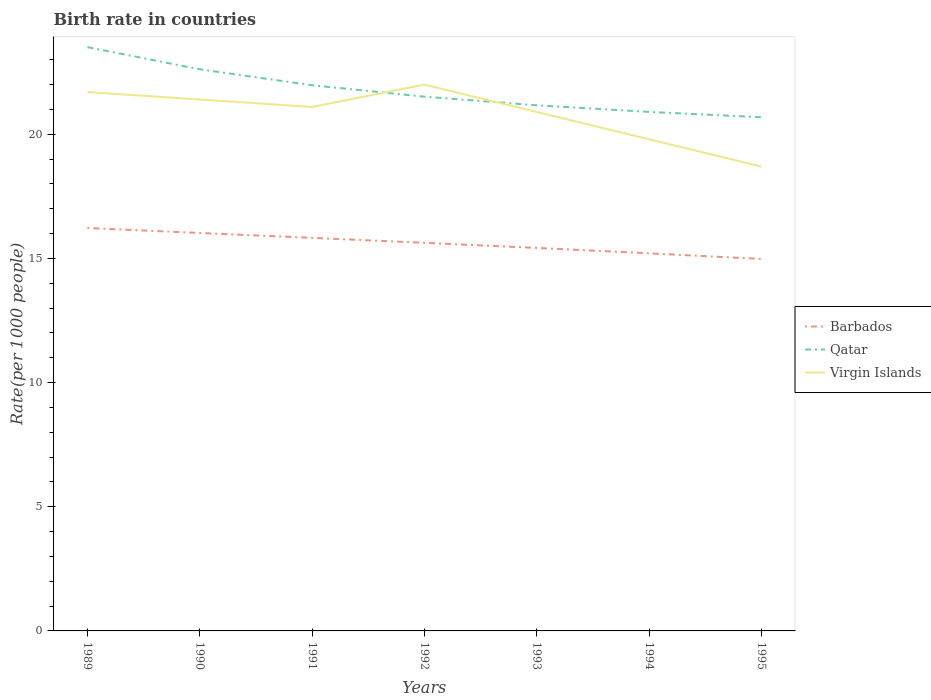Does the line corresponding to Virgin Islands intersect with the line corresponding to Barbados?
Your answer should be compact. No. Is the number of lines equal to the number of legend labels?
Your response must be concise. Yes. Across all years, what is the maximum birth rate in Barbados?
Make the answer very short. 14.98. What is the total birth rate in Qatar in the graph?
Keep it short and to the point. 2.61. What is the difference between the highest and the second highest birth rate in Virgin Islands?
Provide a succinct answer. 3.3. How many years are there in the graph?
Make the answer very short. 7. What is the difference between two consecutive major ticks on the Y-axis?
Give a very brief answer. 5. Are the values on the major ticks of Y-axis written in scientific E-notation?
Your answer should be very brief. No. Where does the legend appear in the graph?
Offer a terse response. Center right. How are the legend labels stacked?
Make the answer very short. Vertical. What is the title of the graph?
Your answer should be very brief. Birth rate in countries. Does "Middle East & North Africa (all income levels)" appear as one of the legend labels in the graph?
Offer a terse response. No. What is the label or title of the X-axis?
Your answer should be compact. Years. What is the label or title of the Y-axis?
Your response must be concise. Rate(per 1000 people). What is the Rate(per 1000 people) in Barbados in 1989?
Your answer should be very brief. 16.23. What is the Rate(per 1000 people) of Qatar in 1989?
Offer a terse response. 23.51. What is the Rate(per 1000 people) in Virgin Islands in 1989?
Make the answer very short. 21.7. What is the Rate(per 1000 people) in Barbados in 1990?
Give a very brief answer. 16.02. What is the Rate(per 1000 people) in Qatar in 1990?
Make the answer very short. 22.62. What is the Rate(per 1000 people) of Virgin Islands in 1990?
Provide a succinct answer. 21.4. What is the Rate(per 1000 people) in Barbados in 1991?
Your answer should be very brief. 15.83. What is the Rate(per 1000 people) in Qatar in 1991?
Your answer should be very brief. 21.98. What is the Rate(per 1000 people) in Virgin Islands in 1991?
Your response must be concise. 21.1. What is the Rate(per 1000 people) in Barbados in 1992?
Your answer should be very brief. 15.63. What is the Rate(per 1000 people) of Qatar in 1992?
Offer a terse response. 21.51. What is the Rate(per 1000 people) of Virgin Islands in 1992?
Your response must be concise. 22. What is the Rate(per 1000 people) in Barbados in 1993?
Keep it short and to the point. 15.42. What is the Rate(per 1000 people) in Qatar in 1993?
Ensure brevity in your answer.  21.17. What is the Rate(per 1000 people) of Virgin Islands in 1993?
Provide a succinct answer. 20.9. What is the Rate(per 1000 people) of Barbados in 1994?
Offer a very short reply. 15.21. What is the Rate(per 1000 people) in Qatar in 1994?
Keep it short and to the point. 20.9. What is the Rate(per 1000 people) of Virgin Islands in 1994?
Offer a very short reply. 19.8. What is the Rate(per 1000 people) in Barbados in 1995?
Keep it short and to the point. 14.98. What is the Rate(per 1000 people) of Qatar in 1995?
Offer a terse response. 20.69. Across all years, what is the maximum Rate(per 1000 people) in Barbados?
Provide a succinct answer. 16.23. Across all years, what is the maximum Rate(per 1000 people) in Qatar?
Make the answer very short. 23.51. Across all years, what is the maximum Rate(per 1000 people) in Virgin Islands?
Your answer should be compact. 22. Across all years, what is the minimum Rate(per 1000 people) in Barbados?
Your response must be concise. 14.98. Across all years, what is the minimum Rate(per 1000 people) of Qatar?
Ensure brevity in your answer.  20.69. What is the total Rate(per 1000 people) of Barbados in the graph?
Keep it short and to the point. 109.32. What is the total Rate(per 1000 people) of Qatar in the graph?
Your answer should be compact. 152.37. What is the total Rate(per 1000 people) of Virgin Islands in the graph?
Your answer should be compact. 145.6. What is the difference between the Rate(per 1000 people) of Barbados in 1989 and that in 1990?
Provide a short and direct response. 0.2. What is the difference between the Rate(per 1000 people) in Qatar in 1989 and that in 1990?
Provide a short and direct response. 0.89. What is the difference between the Rate(per 1000 people) of Barbados in 1989 and that in 1991?
Your response must be concise. 0.4. What is the difference between the Rate(per 1000 people) in Qatar in 1989 and that in 1991?
Give a very brief answer. 1.53. What is the difference between the Rate(per 1000 people) in Barbados in 1989 and that in 1992?
Your answer should be very brief. 0.6. What is the difference between the Rate(per 1000 people) of Qatar in 1989 and that in 1992?
Your response must be concise. 1.99. What is the difference between the Rate(per 1000 people) of Barbados in 1989 and that in 1993?
Make the answer very short. 0.8. What is the difference between the Rate(per 1000 people) of Qatar in 1989 and that in 1993?
Keep it short and to the point. 2.34. What is the difference between the Rate(per 1000 people) in Barbados in 1989 and that in 1994?
Ensure brevity in your answer.  1.02. What is the difference between the Rate(per 1000 people) of Qatar in 1989 and that in 1994?
Give a very brief answer. 2.61. What is the difference between the Rate(per 1000 people) of Barbados in 1989 and that in 1995?
Your response must be concise. 1.25. What is the difference between the Rate(per 1000 people) in Qatar in 1989 and that in 1995?
Give a very brief answer. 2.82. What is the difference between the Rate(per 1000 people) of Virgin Islands in 1989 and that in 1995?
Your answer should be very brief. 3. What is the difference between the Rate(per 1000 people) in Barbados in 1990 and that in 1991?
Provide a short and direct response. 0.2. What is the difference between the Rate(per 1000 people) in Qatar in 1990 and that in 1991?
Your response must be concise. 0.64. What is the difference between the Rate(per 1000 people) in Virgin Islands in 1990 and that in 1991?
Make the answer very short. 0.3. What is the difference between the Rate(per 1000 people) of Barbados in 1990 and that in 1992?
Your answer should be very brief. 0.4. What is the difference between the Rate(per 1000 people) of Qatar in 1990 and that in 1992?
Offer a terse response. 1.1. What is the difference between the Rate(per 1000 people) of Virgin Islands in 1990 and that in 1992?
Offer a terse response. -0.6. What is the difference between the Rate(per 1000 people) in Barbados in 1990 and that in 1993?
Offer a very short reply. 0.6. What is the difference between the Rate(per 1000 people) of Qatar in 1990 and that in 1993?
Make the answer very short. 1.45. What is the difference between the Rate(per 1000 people) in Virgin Islands in 1990 and that in 1993?
Give a very brief answer. 0.5. What is the difference between the Rate(per 1000 people) in Barbados in 1990 and that in 1994?
Offer a terse response. 0.82. What is the difference between the Rate(per 1000 people) of Qatar in 1990 and that in 1994?
Make the answer very short. 1.72. What is the difference between the Rate(per 1000 people) in Barbados in 1990 and that in 1995?
Ensure brevity in your answer.  1.05. What is the difference between the Rate(per 1000 people) in Qatar in 1990 and that in 1995?
Your answer should be very brief. 1.93. What is the difference between the Rate(per 1000 people) of Barbados in 1991 and that in 1992?
Make the answer very short. 0.2. What is the difference between the Rate(per 1000 people) in Qatar in 1991 and that in 1992?
Give a very brief answer. 0.46. What is the difference between the Rate(per 1000 people) in Barbados in 1991 and that in 1993?
Offer a terse response. 0.41. What is the difference between the Rate(per 1000 people) in Qatar in 1991 and that in 1993?
Offer a very short reply. 0.81. What is the difference between the Rate(per 1000 people) in Virgin Islands in 1991 and that in 1993?
Provide a short and direct response. 0.2. What is the difference between the Rate(per 1000 people) of Barbados in 1991 and that in 1994?
Keep it short and to the point. 0.62. What is the difference between the Rate(per 1000 people) in Qatar in 1991 and that in 1994?
Make the answer very short. 1.07. What is the difference between the Rate(per 1000 people) in Virgin Islands in 1991 and that in 1994?
Offer a terse response. 1.3. What is the difference between the Rate(per 1000 people) of Barbados in 1991 and that in 1995?
Make the answer very short. 0.85. What is the difference between the Rate(per 1000 people) of Qatar in 1991 and that in 1995?
Your answer should be compact. 1.29. What is the difference between the Rate(per 1000 people) in Virgin Islands in 1991 and that in 1995?
Provide a succinct answer. 2.4. What is the difference between the Rate(per 1000 people) in Barbados in 1992 and that in 1993?
Your answer should be compact. 0.21. What is the difference between the Rate(per 1000 people) of Qatar in 1992 and that in 1993?
Provide a succinct answer. 0.35. What is the difference between the Rate(per 1000 people) of Virgin Islands in 1992 and that in 1993?
Provide a succinct answer. 1.1. What is the difference between the Rate(per 1000 people) of Barbados in 1992 and that in 1994?
Keep it short and to the point. 0.42. What is the difference between the Rate(per 1000 people) of Qatar in 1992 and that in 1994?
Keep it short and to the point. 0.61. What is the difference between the Rate(per 1000 people) of Virgin Islands in 1992 and that in 1994?
Your answer should be compact. 2.2. What is the difference between the Rate(per 1000 people) of Barbados in 1992 and that in 1995?
Offer a very short reply. 0.65. What is the difference between the Rate(per 1000 people) of Qatar in 1992 and that in 1995?
Your answer should be compact. 0.83. What is the difference between the Rate(per 1000 people) of Barbados in 1993 and that in 1994?
Give a very brief answer. 0.22. What is the difference between the Rate(per 1000 people) in Qatar in 1993 and that in 1994?
Make the answer very short. 0.27. What is the difference between the Rate(per 1000 people) in Barbados in 1993 and that in 1995?
Provide a short and direct response. 0.44. What is the difference between the Rate(per 1000 people) of Qatar in 1993 and that in 1995?
Provide a short and direct response. 0.48. What is the difference between the Rate(per 1000 people) in Barbados in 1994 and that in 1995?
Ensure brevity in your answer.  0.23. What is the difference between the Rate(per 1000 people) of Qatar in 1994 and that in 1995?
Make the answer very short. 0.21. What is the difference between the Rate(per 1000 people) in Virgin Islands in 1994 and that in 1995?
Offer a terse response. 1.1. What is the difference between the Rate(per 1000 people) of Barbados in 1989 and the Rate(per 1000 people) of Qatar in 1990?
Keep it short and to the point. -6.39. What is the difference between the Rate(per 1000 people) of Barbados in 1989 and the Rate(per 1000 people) of Virgin Islands in 1990?
Make the answer very short. -5.17. What is the difference between the Rate(per 1000 people) of Qatar in 1989 and the Rate(per 1000 people) of Virgin Islands in 1990?
Provide a succinct answer. 2.11. What is the difference between the Rate(per 1000 people) in Barbados in 1989 and the Rate(per 1000 people) in Qatar in 1991?
Your answer should be very brief. -5.75. What is the difference between the Rate(per 1000 people) in Barbados in 1989 and the Rate(per 1000 people) in Virgin Islands in 1991?
Your answer should be compact. -4.87. What is the difference between the Rate(per 1000 people) in Qatar in 1989 and the Rate(per 1000 people) in Virgin Islands in 1991?
Offer a terse response. 2.41. What is the difference between the Rate(per 1000 people) in Barbados in 1989 and the Rate(per 1000 people) in Qatar in 1992?
Ensure brevity in your answer.  -5.29. What is the difference between the Rate(per 1000 people) of Barbados in 1989 and the Rate(per 1000 people) of Virgin Islands in 1992?
Offer a very short reply. -5.77. What is the difference between the Rate(per 1000 people) of Qatar in 1989 and the Rate(per 1000 people) of Virgin Islands in 1992?
Provide a short and direct response. 1.51. What is the difference between the Rate(per 1000 people) in Barbados in 1989 and the Rate(per 1000 people) in Qatar in 1993?
Provide a succinct answer. -4.94. What is the difference between the Rate(per 1000 people) in Barbados in 1989 and the Rate(per 1000 people) in Virgin Islands in 1993?
Ensure brevity in your answer.  -4.67. What is the difference between the Rate(per 1000 people) in Qatar in 1989 and the Rate(per 1000 people) in Virgin Islands in 1993?
Give a very brief answer. 2.61. What is the difference between the Rate(per 1000 people) in Barbados in 1989 and the Rate(per 1000 people) in Qatar in 1994?
Your answer should be very brief. -4.67. What is the difference between the Rate(per 1000 people) in Barbados in 1989 and the Rate(per 1000 people) in Virgin Islands in 1994?
Make the answer very short. -3.57. What is the difference between the Rate(per 1000 people) of Qatar in 1989 and the Rate(per 1000 people) of Virgin Islands in 1994?
Your answer should be compact. 3.71. What is the difference between the Rate(per 1000 people) in Barbados in 1989 and the Rate(per 1000 people) in Qatar in 1995?
Make the answer very short. -4.46. What is the difference between the Rate(per 1000 people) in Barbados in 1989 and the Rate(per 1000 people) in Virgin Islands in 1995?
Make the answer very short. -2.47. What is the difference between the Rate(per 1000 people) of Qatar in 1989 and the Rate(per 1000 people) of Virgin Islands in 1995?
Provide a succinct answer. 4.81. What is the difference between the Rate(per 1000 people) in Barbados in 1990 and the Rate(per 1000 people) in Qatar in 1991?
Your answer should be very brief. -5.95. What is the difference between the Rate(per 1000 people) of Barbados in 1990 and the Rate(per 1000 people) of Virgin Islands in 1991?
Your answer should be compact. -5.08. What is the difference between the Rate(per 1000 people) in Qatar in 1990 and the Rate(per 1000 people) in Virgin Islands in 1991?
Give a very brief answer. 1.52. What is the difference between the Rate(per 1000 people) of Barbados in 1990 and the Rate(per 1000 people) of Qatar in 1992?
Provide a succinct answer. -5.49. What is the difference between the Rate(per 1000 people) in Barbados in 1990 and the Rate(per 1000 people) in Virgin Islands in 1992?
Offer a very short reply. -5.97. What is the difference between the Rate(per 1000 people) in Qatar in 1990 and the Rate(per 1000 people) in Virgin Islands in 1992?
Make the answer very short. 0.62. What is the difference between the Rate(per 1000 people) in Barbados in 1990 and the Rate(per 1000 people) in Qatar in 1993?
Ensure brevity in your answer.  -5.14. What is the difference between the Rate(per 1000 people) in Barbados in 1990 and the Rate(per 1000 people) in Virgin Islands in 1993?
Your answer should be compact. -4.88. What is the difference between the Rate(per 1000 people) of Qatar in 1990 and the Rate(per 1000 people) of Virgin Islands in 1993?
Keep it short and to the point. 1.72. What is the difference between the Rate(per 1000 people) in Barbados in 1990 and the Rate(per 1000 people) in Qatar in 1994?
Make the answer very short. -4.88. What is the difference between the Rate(per 1000 people) in Barbados in 1990 and the Rate(per 1000 people) in Virgin Islands in 1994?
Your answer should be very brief. -3.77. What is the difference between the Rate(per 1000 people) of Qatar in 1990 and the Rate(per 1000 people) of Virgin Islands in 1994?
Ensure brevity in your answer.  2.82. What is the difference between the Rate(per 1000 people) of Barbados in 1990 and the Rate(per 1000 people) of Qatar in 1995?
Make the answer very short. -4.66. What is the difference between the Rate(per 1000 people) in Barbados in 1990 and the Rate(per 1000 people) in Virgin Islands in 1995?
Keep it short and to the point. -2.67. What is the difference between the Rate(per 1000 people) of Qatar in 1990 and the Rate(per 1000 people) of Virgin Islands in 1995?
Keep it short and to the point. 3.92. What is the difference between the Rate(per 1000 people) in Barbados in 1991 and the Rate(per 1000 people) in Qatar in 1992?
Make the answer very short. -5.68. What is the difference between the Rate(per 1000 people) in Barbados in 1991 and the Rate(per 1000 people) in Virgin Islands in 1992?
Your answer should be compact. -6.17. What is the difference between the Rate(per 1000 people) in Qatar in 1991 and the Rate(per 1000 people) in Virgin Islands in 1992?
Offer a terse response. -0.03. What is the difference between the Rate(per 1000 people) in Barbados in 1991 and the Rate(per 1000 people) in Qatar in 1993?
Your answer should be very brief. -5.34. What is the difference between the Rate(per 1000 people) of Barbados in 1991 and the Rate(per 1000 people) of Virgin Islands in 1993?
Offer a very short reply. -5.07. What is the difference between the Rate(per 1000 people) in Qatar in 1991 and the Rate(per 1000 people) in Virgin Islands in 1993?
Make the answer very short. 1.07. What is the difference between the Rate(per 1000 people) of Barbados in 1991 and the Rate(per 1000 people) of Qatar in 1994?
Give a very brief answer. -5.07. What is the difference between the Rate(per 1000 people) in Barbados in 1991 and the Rate(per 1000 people) in Virgin Islands in 1994?
Keep it short and to the point. -3.97. What is the difference between the Rate(per 1000 people) of Qatar in 1991 and the Rate(per 1000 people) of Virgin Islands in 1994?
Your response must be concise. 2.17. What is the difference between the Rate(per 1000 people) in Barbados in 1991 and the Rate(per 1000 people) in Qatar in 1995?
Offer a terse response. -4.86. What is the difference between the Rate(per 1000 people) of Barbados in 1991 and the Rate(per 1000 people) of Virgin Islands in 1995?
Offer a terse response. -2.87. What is the difference between the Rate(per 1000 people) in Qatar in 1991 and the Rate(per 1000 people) in Virgin Islands in 1995?
Your answer should be very brief. 3.27. What is the difference between the Rate(per 1000 people) in Barbados in 1992 and the Rate(per 1000 people) in Qatar in 1993?
Make the answer very short. -5.54. What is the difference between the Rate(per 1000 people) of Barbados in 1992 and the Rate(per 1000 people) of Virgin Islands in 1993?
Your answer should be compact. -5.27. What is the difference between the Rate(per 1000 people) of Qatar in 1992 and the Rate(per 1000 people) of Virgin Islands in 1993?
Provide a succinct answer. 0.61. What is the difference between the Rate(per 1000 people) in Barbados in 1992 and the Rate(per 1000 people) in Qatar in 1994?
Your answer should be compact. -5.27. What is the difference between the Rate(per 1000 people) in Barbados in 1992 and the Rate(per 1000 people) in Virgin Islands in 1994?
Keep it short and to the point. -4.17. What is the difference between the Rate(per 1000 people) of Qatar in 1992 and the Rate(per 1000 people) of Virgin Islands in 1994?
Provide a short and direct response. 1.71. What is the difference between the Rate(per 1000 people) in Barbados in 1992 and the Rate(per 1000 people) in Qatar in 1995?
Offer a very short reply. -5.06. What is the difference between the Rate(per 1000 people) of Barbados in 1992 and the Rate(per 1000 people) of Virgin Islands in 1995?
Your answer should be very brief. -3.07. What is the difference between the Rate(per 1000 people) in Qatar in 1992 and the Rate(per 1000 people) in Virgin Islands in 1995?
Your answer should be very brief. 2.81. What is the difference between the Rate(per 1000 people) in Barbados in 1993 and the Rate(per 1000 people) in Qatar in 1994?
Offer a terse response. -5.48. What is the difference between the Rate(per 1000 people) of Barbados in 1993 and the Rate(per 1000 people) of Virgin Islands in 1994?
Offer a terse response. -4.38. What is the difference between the Rate(per 1000 people) in Qatar in 1993 and the Rate(per 1000 people) in Virgin Islands in 1994?
Offer a terse response. 1.37. What is the difference between the Rate(per 1000 people) in Barbados in 1993 and the Rate(per 1000 people) in Qatar in 1995?
Provide a short and direct response. -5.26. What is the difference between the Rate(per 1000 people) of Barbados in 1993 and the Rate(per 1000 people) of Virgin Islands in 1995?
Keep it short and to the point. -3.28. What is the difference between the Rate(per 1000 people) of Qatar in 1993 and the Rate(per 1000 people) of Virgin Islands in 1995?
Ensure brevity in your answer.  2.47. What is the difference between the Rate(per 1000 people) in Barbados in 1994 and the Rate(per 1000 people) in Qatar in 1995?
Ensure brevity in your answer.  -5.48. What is the difference between the Rate(per 1000 people) of Barbados in 1994 and the Rate(per 1000 people) of Virgin Islands in 1995?
Your answer should be very brief. -3.49. What is the difference between the Rate(per 1000 people) in Qatar in 1994 and the Rate(per 1000 people) in Virgin Islands in 1995?
Give a very brief answer. 2.2. What is the average Rate(per 1000 people) in Barbados per year?
Provide a short and direct response. 15.62. What is the average Rate(per 1000 people) of Qatar per year?
Give a very brief answer. 21.77. What is the average Rate(per 1000 people) in Virgin Islands per year?
Give a very brief answer. 20.8. In the year 1989, what is the difference between the Rate(per 1000 people) of Barbados and Rate(per 1000 people) of Qatar?
Keep it short and to the point. -7.28. In the year 1989, what is the difference between the Rate(per 1000 people) in Barbados and Rate(per 1000 people) in Virgin Islands?
Provide a short and direct response. -5.47. In the year 1989, what is the difference between the Rate(per 1000 people) of Qatar and Rate(per 1000 people) of Virgin Islands?
Your answer should be compact. 1.81. In the year 1990, what is the difference between the Rate(per 1000 people) of Barbados and Rate(per 1000 people) of Qatar?
Make the answer very short. -6.59. In the year 1990, what is the difference between the Rate(per 1000 people) of Barbados and Rate(per 1000 people) of Virgin Islands?
Offer a very short reply. -5.38. In the year 1990, what is the difference between the Rate(per 1000 people) in Qatar and Rate(per 1000 people) in Virgin Islands?
Your answer should be compact. 1.22. In the year 1991, what is the difference between the Rate(per 1000 people) in Barbados and Rate(per 1000 people) in Qatar?
Keep it short and to the point. -6.15. In the year 1991, what is the difference between the Rate(per 1000 people) of Barbados and Rate(per 1000 people) of Virgin Islands?
Keep it short and to the point. -5.27. In the year 1991, what is the difference between the Rate(per 1000 people) in Qatar and Rate(per 1000 people) in Virgin Islands?
Offer a very short reply. 0.88. In the year 1992, what is the difference between the Rate(per 1000 people) of Barbados and Rate(per 1000 people) of Qatar?
Offer a very short reply. -5.88. In the year 1992, what is the difference between the Rate(per 1000 people) in Barbados and Rate(per 1000 people) in Virgin Islands?
Provide a short and direct response. -6.37. In the year 1992, what is the difference between the Rate(per 1000 people) of Qatar and Rate(per 1000 people) of Virgin Islands?
Provide a short and direct response. -0.49. In the year 1993, what is the difference between the Rate(per 1000 people) of Barbados and Rate(per 1000 people) of Qatar?
Ensure brevity in your answer.  -5.75. In the year 1993, what is the difference between the Rate(per 1000 people) in Barbados and Rate(per 1000 people) in Virgin Islands?
Give a very brief answer. -5.48. In the year 1993, what is the difference between the Rate(per 1000 people) in Qatar and Rate(per 1000 people) in Virgin Islands?
Your answer should be compact. 0.27. In the year 1994, what is the difference between the Rate(per 1000 people) of Barbados and Rate(per 1000 people) of Qatar?
Offer a terse response. -5.7. In the year 1994, what is the difference between the Rate(per 1000 people) in Barbados and Rate(per 1000 people) in Virgin Islands?
Offer a terse response. -4.59. In the year 1994, what is the difference between the Rate(per 1000 people) of Qatar and Rate(per 1000 people) of Virgin Islands?
Ensure brevity in your answer.  1.1. In the year 1995, what is the difference between the Rate(per 1000 people) in Barbados and Rate(per 1000 people) in Qatar?
Make the answer very short. -5.71. In the year 1995, what is the difference between the Rate(per 1000 people) of Barbados and Rate(per 1000 people) of Virgin Islands?
Your answer should be compact. -3.72. In the year 1995, what is the difference between the Rate(per 1000 people) of Qatar and Rate(per 1000 people) of Virgin Islands?
Give a very brief answer. 1.99. What is the ratio of the Rate(per 1000 people) of Barbados in 1989 to that in 1990?
Ensure brevity in your answer.  1.01. What is the ratio of the Rate(per 1000 people) in Qatar in 1989 to that in 1990?
Offer a very short reply. 1.04. What is the ratio of the Rate(per 1000 people) in Barbados in 1989 to that in 1991?
Your response must be concise. 1.03. What is the ratio of the Rate(per 1000 people) in Qatar in 1989 to that in 1991?
Keep it short and to the point. 1.07. What is the ratio of the Rate(per 1000 people) in Virgin Islands in 1989 to that in 1991?
Your answer should be very brief. 1.03. What is the ratio of the Rate(per 1000 people) in Barbados in 1989 to that in 1992?
Your answer should be very brief. 1.04. What is the ratio of the Rate(per 1000 people) in Qatar in 1989 to that in 1992?
Provide a succinct answer. 1.09. What is the ratio of the Rate(per 1000 people) of Virgin Islands in 1989 to that in 1992?
Ensure brevity in your answer.  0.99. What is the ratio of the Rate(per 1000 people) in Barbados in 1989 to that in 1993?
Provide a short and direct response. 1.05. What is the ratio of the Rate(per 1000 people) in Qatar in 1989 to that in 1993?
Provide a short and direct response. 1.11. What is the ratio of the Rate(per 1000 people) of Virgin Islands in 1989 to that in 1993?
Provide a succinct answer. 1.04. What is the ratio of the Rate(per 1000 people) in Barbados in 1989 to that in 1994?
Your answer should be compact. 1.07. What is the ratio of the Rate(per 1000 people) in Qatar in 1989 to that in 1994?
Keep it short and to the point. 1.12. What is the ratio of the Rate(per 1000 people) in Virgin Islands in 1989 to that in 1994?
Your response must be concise. 1.1. What is the ratio of the Rate(per 1000 people) of Barbados in 1989 to that in 1995?
Your answer should be compact. 1.08. What is the ratio of the Rate(per 1000 people) of Qatar in 1989 to that in 1995?
Offer a terse response. 1.14. What is the ratio of the Rate(per 1000 people) of Virgin Islands in 1989 to that in 1995?
Give a very brief answer. 1.16. What is the ratio of the Rate(per 1000 people) of Barbados in 1990 to that in 1991?
Offer a very short reply. 1.01. What is the ratio of the Rate(per 1000 people) in Qatar in 1990 to that in 1991?
Keep it short and to the point. 1.03. What is the ratio of the Rate(per 1000 people) in Virgin Islands in 1990 to that in 1991?
Ensure brevity in your answer.  1.01. What is the ratio of the Rate(per 1000 people) in Barbados in 1990 to that in 1992?
Keep it short and to the point. 1.03. What is the ratio of the Rate(per 1000 people) of Qatar in 1990 to that in 1992?
Give a very brief answer. 1.05. What is the ratio of the Rate(per 1000 people) in Virgin Islands in 1990 to that in 1992?
Give a very brief answer. 0.97. What is the ratio of the Rate(per 1000 people) in Barbados in 1990 to that in 1993?
Offer a very short reply. 1.04. What is the ratio of the Rate(per 1000 people) of Qatar in 1990 to that in 1993?
Your answer should be compact. 1.07. What is the ratio of the Rate(per 1000 people) of Virgin Islands in 1990 to that in 1993?
Provide a short and direct response. 1.02. What is the ratio of the Rate(per 1000 people) of Barbados in 1990 to that in 1994?
Offer a very short reply. 1.05. What is the ratio of the Rate(per 1000 people) in Qatar in 1990 to that in 1994?
Your answer should be compact. 1.08. What is the ratio of the Rate(per 1000 people) of Virgin Islands in 1990 to that in 1994?
Your answer should be compact. 1.08. What is the ratio of the Rate(per 1000 people) of Barbados in 1990 to that in 1995?
Offer a terse response. 1.07. What is the ratio of the Rate(per 1000 people) in Qatar in 1990 to that in 1995?
Offer a very short reply. 1.09. What is the ratio of the Rate(per 1000 people) in Virgin Islands in 1990 to that in 1995?
Offer a terse response. 1.14. What is the ratio of the Rate(per 1000 people) of Barbados in 1991 to that in 1992?
Provide a succinct answer. 1.01. What is the ratio of the Rate(per 1000 people) in Qatar in 1991 to that in 1992?
Offer a terse response. 1.02. What is the ratio of the Rate(per 1000 people) of Virgin Islands in 1991 to that in 1992?
Your response must be concise. 0.96. What is the ratio of the Rate(per 1000 people) of Barbados in 1991 to that in 1993?
Ensure brevity in your answer.  1.03. What is the ratio of the Rate(per 1000 people) of Qatar in 1991 to that in 1993?
Ensure brevity in your answer.  1.04. What is the ratio of the Rate(per 1000 people) in Virgin Islands in 1991 to that in 1993?
Your response must be concise. 1.01. What is the ratio of the Rate(per 1000 people) of Barbados in 1991 to that in 1994?
Your answer should be compact. 1.04. What is the ratio of the Rate(per 1000 people) in Qatar in 1991 to that in 1994?
Keep it short and to the point. 1.05. What is the ratio of the Rate(per 1000 people) of Virgin Islands in 1991 to that in 1994?
Your answer should be very brief. 1.07. What is the ratio of the Rate(per 1000 people) of Barbados in 1991 to that in 1995?
Give a very brief answer. 1.06. What is the ratio of the Rate(per 1000 people) in Qatar in 1991 to that in 1995?
Offer a terse response. 1.06. What is the ratio of the Rate(per 1000 people) of Virgin Islands in 1991 to that in 1995?
Make the answer very short. 1.13. What is the ratio of the Rate(per 1000 people) in Barbados in 1992 to that in 1993?
Provide a succinct answer. 1.01. What is the ratio of the Rate(per 1000 people) in Qatar in 1992 to that in 1993?
Ensure brevity in your answer.  1.02. What is the ratio of the Rate(per 1000 people) in Virgin Islands in 1992 to that in 1993?
Offer a terse response. 1.05. What is the ratio of the Rate(per 1000 people) of Barbados in 1992 to that in 1994?
Provide a short and direct response. 1.03. What is the ratio of the Rate(per 1000 people) in Qatar in 1992 to that in 1994?
Offer a very short reply. 1.03. What is the ratio of the Rate(per 1000 people) of Barbados in 1992 to that in 1995?
Your response must be concise. 1.04. What is the ratio of the Rate(per 1000 people) in Virgin Islands in 1992 to that in 1995?
Your answer should be very brief. 1.18. What is the ratio of the Rate(per 1000 people) of Barbados in 1993 to that in 1994?
Your response must be concise. 1.01. What is the ratio of the Rate(per 1000 people) of Qatar in 1993 to that in 1994?
Your answer should be very brief. 1.01. What is the ratio of the Rate(per 1000 people) of Virgin Islands in 1993 to that in 1994?
Your response must be concise. 1.06. What is the ratio of the Rate(per 1000 people) of Barbados in 1993 to that in 1995?
Keep it short and to the point. 1.03. What is the ratio of the Rate(per 1000 people) of Qatar in 1993 to that in 1995?
Keep it short and to the point. 1.02. What is the ratio of the Rate(per 1000 people) of Virgin Islands in 1993 to that in 1995?
Your answer should be compact. 1.12. What is the ratio of the Rate(per 1000 people) of Barbados in 1994 to that in 1995?
Provide a succinct answer. 1.02. What is the ratio of the Rate(per 1000 people) of Qatar in 1994 to that in 1995?
Keep it short and to the point. 1.01. What is the ratio of the Rate(per 1000 people) in Virgin Islands in 1994 to that in 1995?
Provide a succinct answer. 1.06. What is the difference between the highest and the second highest Rate(per 1000 people) in Barbados?
Make the answer very short. 0.2. What is the difference between the highest and the second highest Rate(per 1000 people) in Qatar?
Your response must be concise. 0.89. What is the difference between the highest and the second highest Rate(per 1000 people) in Virgin Islands?
Offer a very short reply. 0.3. What is the difference between the highest and the lowest Rate(per 1000 people) in Barbados?
Your response must be concise. 1.25. What is the difference between the highest and the lowest Rate(per 1000 people) in Qatar?
Your response must be concise. 2.82. 